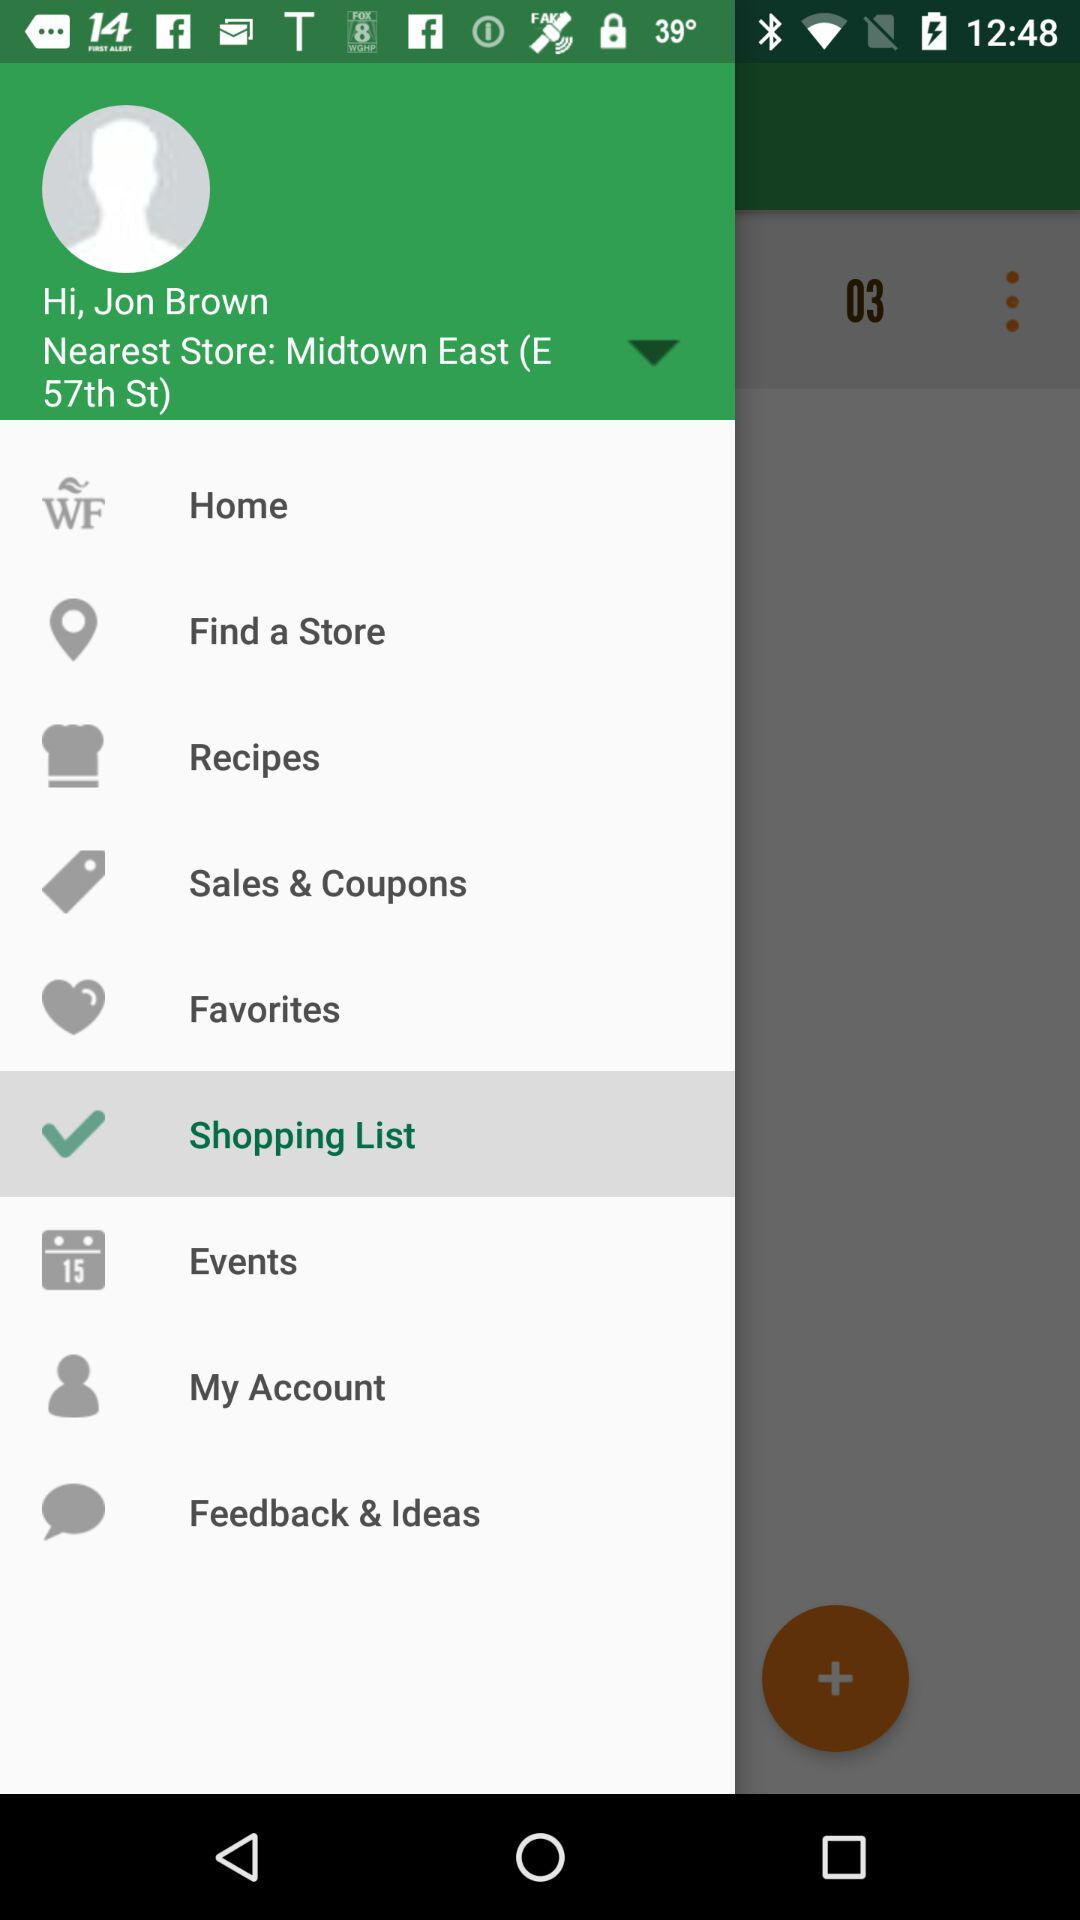What is the status of the shopping list?
When the provided information is insufficient, respond with <no answer>. <no answer> 